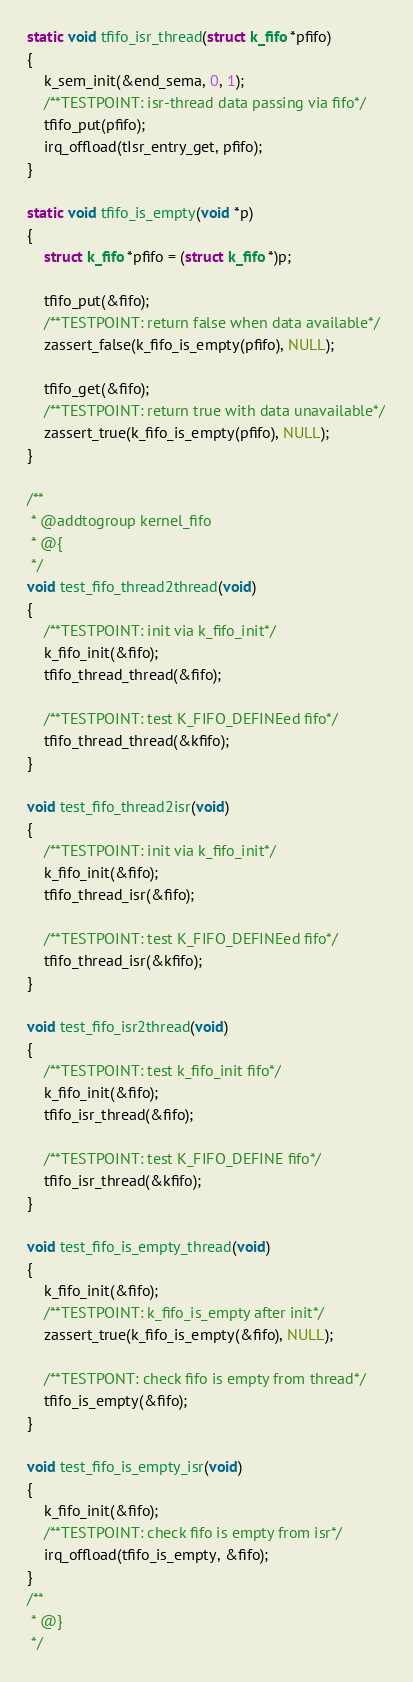Convert code to text. <code><loc_0><loc_0><loc_500><loc_500><_C_>
static void tfifo_isr_thread(struct k_fifo *pfifo)
{
	k_sem_init(&end_sema, 0, 1);
	/**TESTPOINT: isr-thread data passing via fifo*/
	tfifo_put(pfifo);
	irq_offload(tIsr_entry_get, pfifo);
}

static void tfifo_is_empty(void *p)
{
	struct k_fifo *pfifo = (struct k_fifo *)p;

	tfifo_put(&fifo);
	/**TESTPOINT: return false when data available*/
	zassert_false(k_fifo_is_empty(pfifo), NULL);

	tfifo_get(&fifo);
	/**TESTPOINT: return true with data unavailable*/
	zassert_true(k_fifo_is_empty(pfifo), NULL);
}

/**
 * @addtogroup kernel_fifo
 * @{
 */
void test_fifo_thread2thread(void)
{
	/**TESTPOINT: init via k_fifo_init*/
	k_fifo_init(&fifo);
	tfifo_thread_thread(&fifo);

	/**TESTPOINT: test K_FIFO_DEFINEed fifo*/
	tfifo_thread_thread(&kfifo);
}

void test_fifo_thread2isr(void)
{
	/**TESTPOINT: init via k_fifo_init*/
	k_fifo_init(&fifo);
	tfifo_thread_isr(&fifo);

	/**TESTPOINT: test K_FIFO_DEFINEed fifo*/
	tfifo_thread_isr(&kfifo);
}

void test_fifo_isr2thread(void)
{
	/**TESTPOINT: test k_fifo_init fifo*/
	k_fifo_init(&fifo);
	tfifo_isr_thread(&fifo);

	/**TESTPOINT: test K_FIFO_DEFINE fifo*/
	tfifo_isr_thread(&kfifo);
}

void test_fifo_is_empty_thread(void)
{
	k_fifo_init(&fifo);
	/**TESTPOINT: k_fifo_is_empty after init*/
	zassert_true(k_fifo_is_empty(&fifo), NULL);

	/**TESTPONT: check fifo is empty from thread*/
	tfifo_is_empty(&fifo);
}

void test_fifo_is_empty_isr(void)
{
	k_fifo_init(&fifo);
	/**TESTPOINT: check fifo is empty from isr*/
	irq_offload(tfifo_is_empty, &fifo);
}
/**
 * @}
 */
</code> 